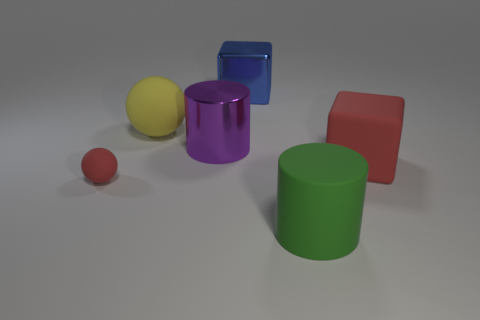Subtract all cyan balls. Subtract all blue cubes. How many balls are left? 2 Add 1 large brown metallic balls. How many objects exist? 7 Subtract all spheres. How many objects are left? 4 Subtract 0 cyan cubes. How many objects are left? 6 Subtract all rubber things. Subtract all big red rubber cylinders. How many objects are left? 2 Add 3 blocks. How many blocks are left? 5 Add 3 big blue spheres. How many big blue spheres exist? 3 